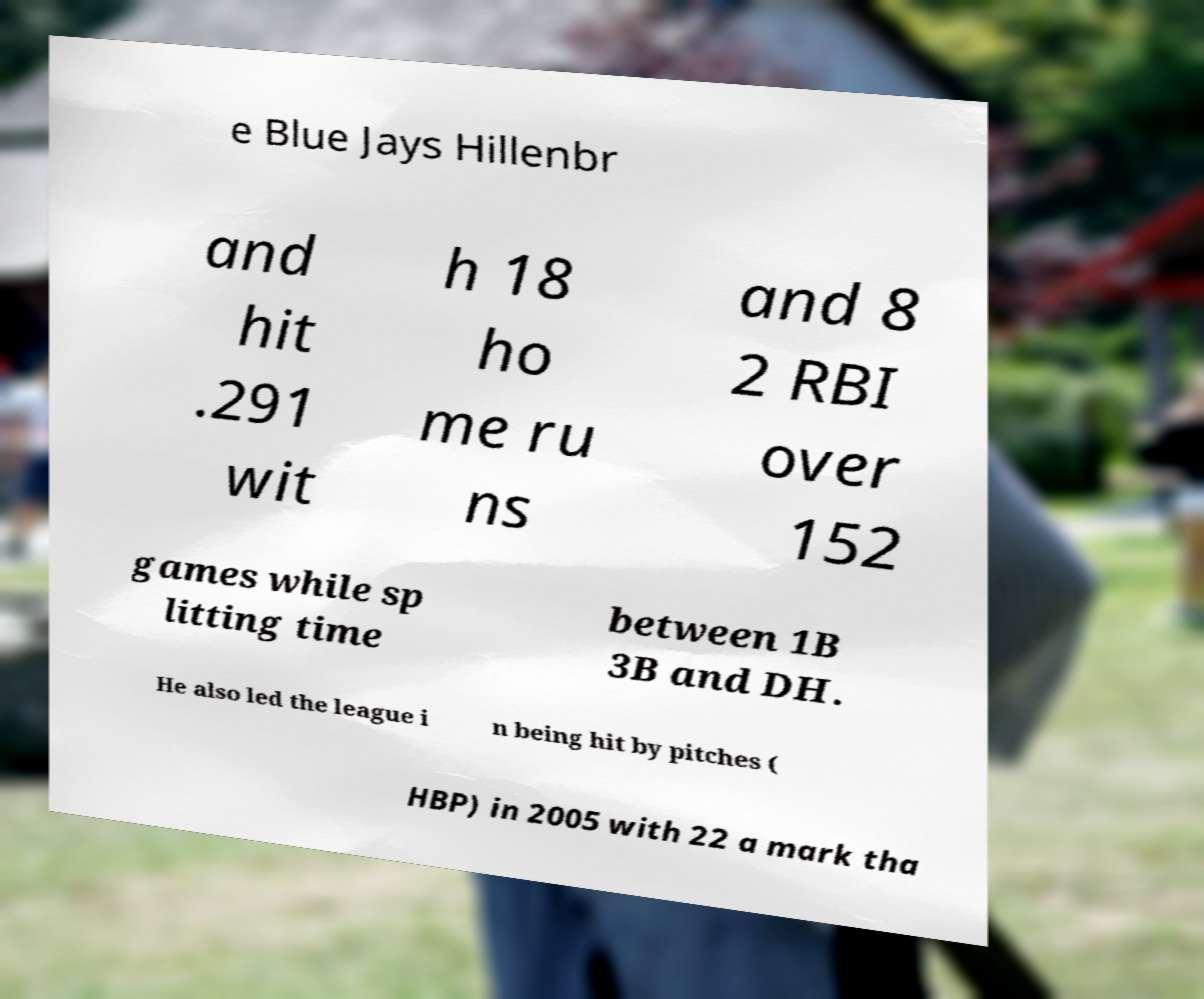What messages or text are displayed in this image? I need them in a readable, typed format. e Blue Jays Hillenbr and hit .291 wit h 18 ho me ru ns and 8 2 RBI over 152 games while sp litting time between 1B 3B and DH. He also led the league i n being hit by pitches ( HBP) in 2005 with 22 a mark tha 